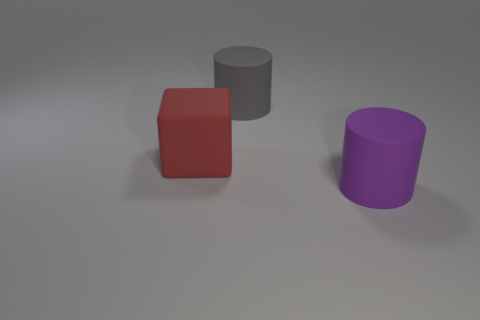Add 1 big gray cylinders. How many objects exist? 4 Subtract all yellow blocks. How many gray cylinders are left? 1 Subtract all matte blocks. Subtract all big cubes. How many objects are left? 1 Add 1 big purple rubber things. How many big purple rubber things are left? 2 Add 2 big yellow metal cubes. How many big yellow metal cubes exist? 2 Subtract all gray cylinders. How many cylinders are left? 1 Subtract 0 brown spheres. How many objects are left? 3 Subtract all blocks. How many objects are left? 2 Subtract all purple cylinders. Subtract all brown balls. How many cylinders are left? 1 